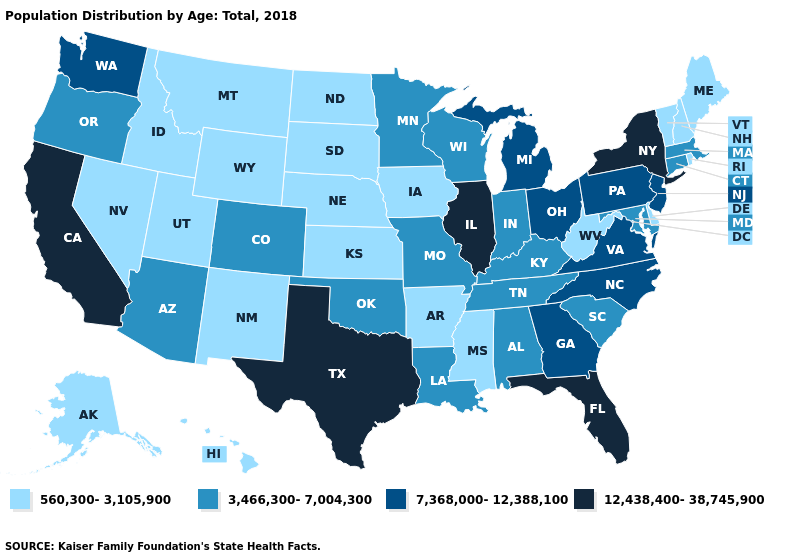Name the states that have a value in the range 7,368,000-12,388,100?
Quick response, please. Georgia, Michigan, New Jersey, North Carolina, Ohio, Pennsylvania, Virginia, Washington. Does the first symbol in the legend represent the smallest category?
Be succinct. Yes. Among the states that border Kansas , does Nebraska have the highest value?
Concise answer only. No. What is the highest value in the USA?
Quick response, please. 12,438,400-38,745,900. Which states have the lowest value in the USA?
Answer briefly. Alaska, Arkansas, Delaware, Hawaii, Idaho, Iowa, Kansas, Maine, Mississippi, Montana, Nebraska, Nevada, New Hampshire, New Mexico, North Dakota, Rhode Island, South Dakota, Utah, Vermont, West Virginia, Wyoming. Does Louisiana have the same value as Oregon?
Quick response, please. Yes. What is the lowest value in the West?
Give a very brief answer. 560,300-3,105,900. Does New York have the lowest value in the Northeast?
Give a very brief answer. No. What is the value of Louisiana?
Quick response, please. 3,466,300-7,004,300. What is the lowest value in the USA?
Concise answer only. 560,300-3,105,900. What is the value of Idaho?
Give a very brief answer. 560,300-3,105,900. What is the value of Rhode Island?
Be succinct. 560,300-3,105,900. Name the states that have a value in the range 12,438,400-38,745,900?
Concise answer only. California, Florida, Illinois, New York, Texas. What is the highest value in states that border Iowa?
Short answer required. 12,438,400-38,745,900. Name the states that have a value in the range 3,466,300-7,004,300?
Answer briefly. Alabama, Arizona, Colorado, Connecticut, Indiana, Kentucky, Louisiana, Maryland, Massachusetts, Minnesota, Missouri, Oklahoma, Oregon, South Carolina, Tennessee, Wisconsin. 